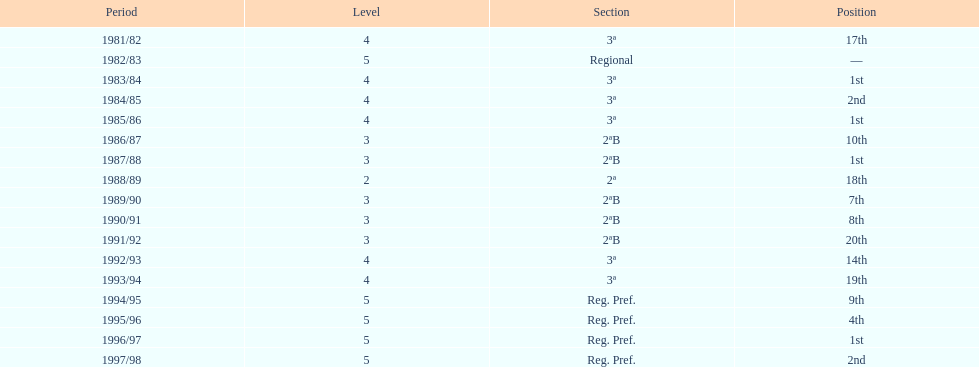How many seasons are shown in this chart? 17. 